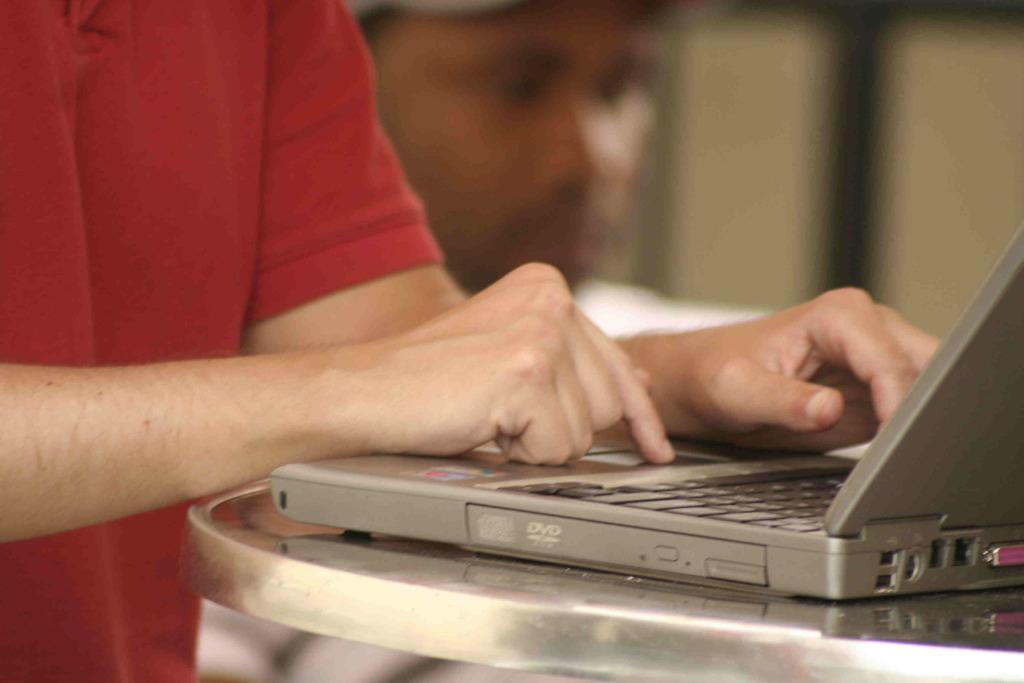<image>
Present a compact description of the photo's key features. A man wearing a red shirt is typing on a silver computer near the DVD compartment 